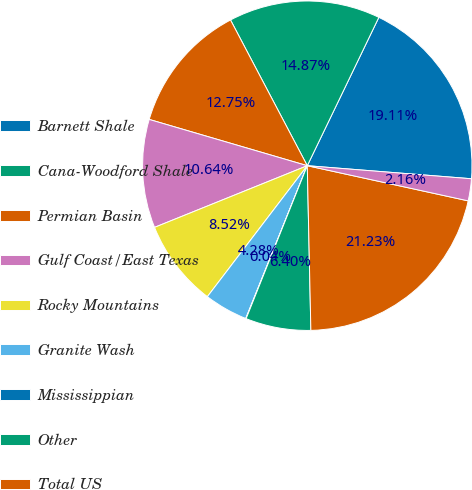Convert chart to OTSL. <chart><loc_0><loc_0><loc_500><loc_500><pie_chart><fcel>Barnett Shale<fcel>Cana-Woodford Shale<fcel>Permian Basin<fcel>Gulf Coast/East Texas<fcel>Rocky Mountains<fcel>Granite Wash<fcel>Mississippian<fcel>Other<fcel>Total US<fcel>Lloydminster<nl><fcel>19.11%<fcel>14.87%<fcel>12.75%<fcel>10.64%<fcel>8.52%<fcel>4.28%<fcel>0.04%<fcel>6.4%<fcel>21.23%<fcel>2.16%<nl></chart> 